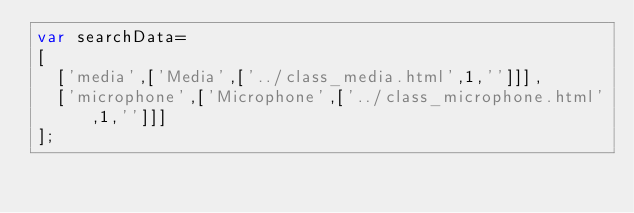<code> <loc_0><loc_0><loc_500><loc_500><_JavaScript_>var searchData=
[
  ['media',['Media',['../class_media.html',1,'']]],
  ['microphone',['Microphone',['../class_microphone.html',1,'']]]
];
</code> 